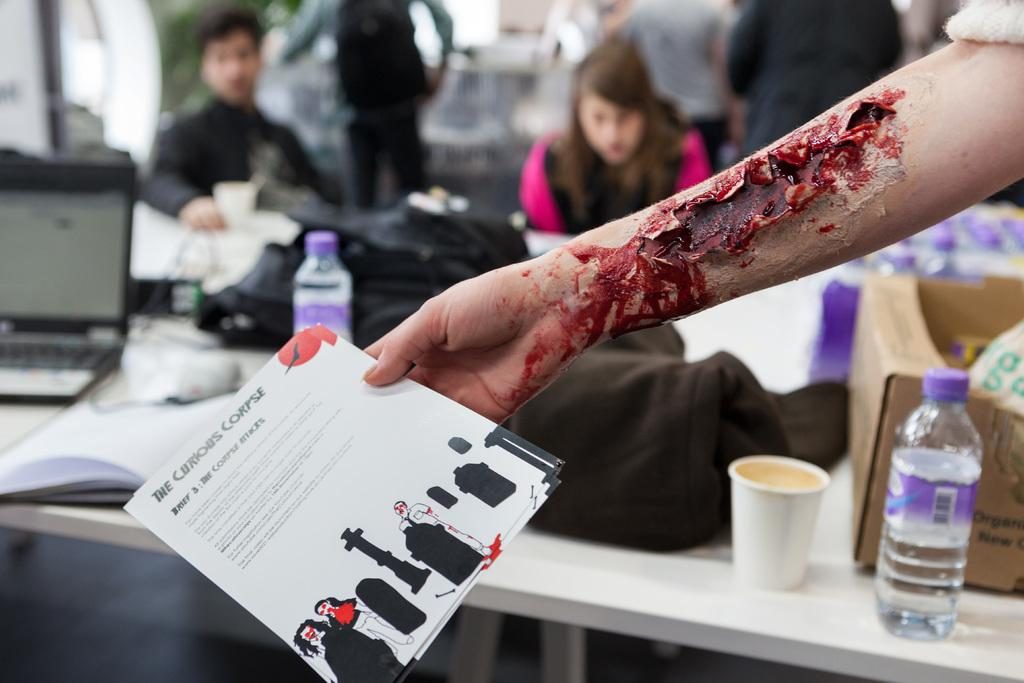What is the person holding in the image? There is a hand of a person holding a paper in the image. What objects can be seen on the table in the image? There are bottles, a cup, and a laptop on the table in the image. Are there any other people visible in the image? Yes, there are other people visible in the image. What type of unit can be seen adjusting the laptop in the image? There is no unit present in the image, and the laptop is not being adjusted. 